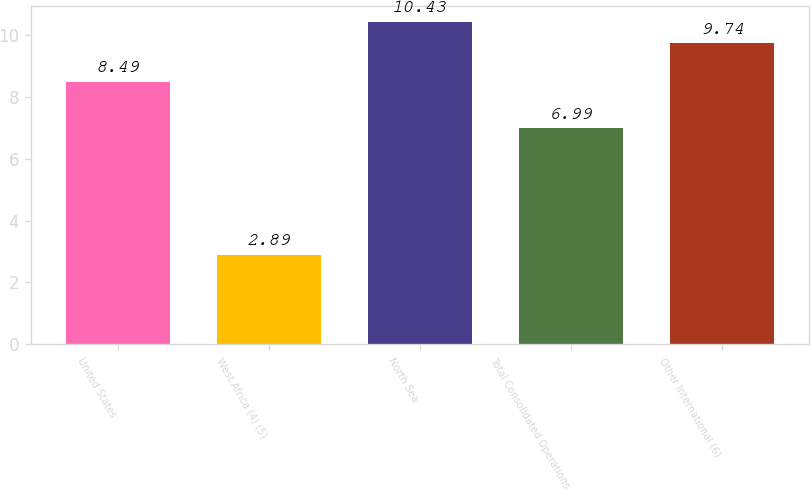Convert chart. <chart><loc_0><loc_0><loc_500><loc_500><bar_chart><fcel>United States<fcel>West Africa (4) (5)<fcel>North Sea<fcel>Total Consolidated Operations<fcel>Other International (6)<nl><fcel>8.49<fcel>2.89<fcel>10.43<fcel>6.99<fcel>9.74<nl></chart> 